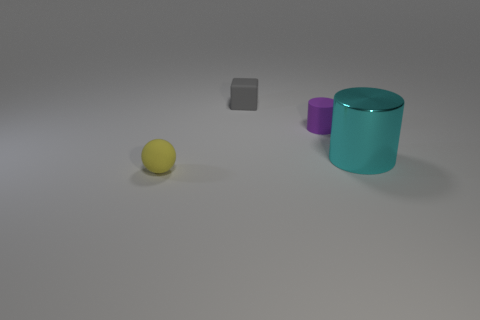What number of things are small gray rubber cubes or small balls? In the image, there is one small gray rubber cube and one small yellow ball, making a total of two items that meet the criteria. 